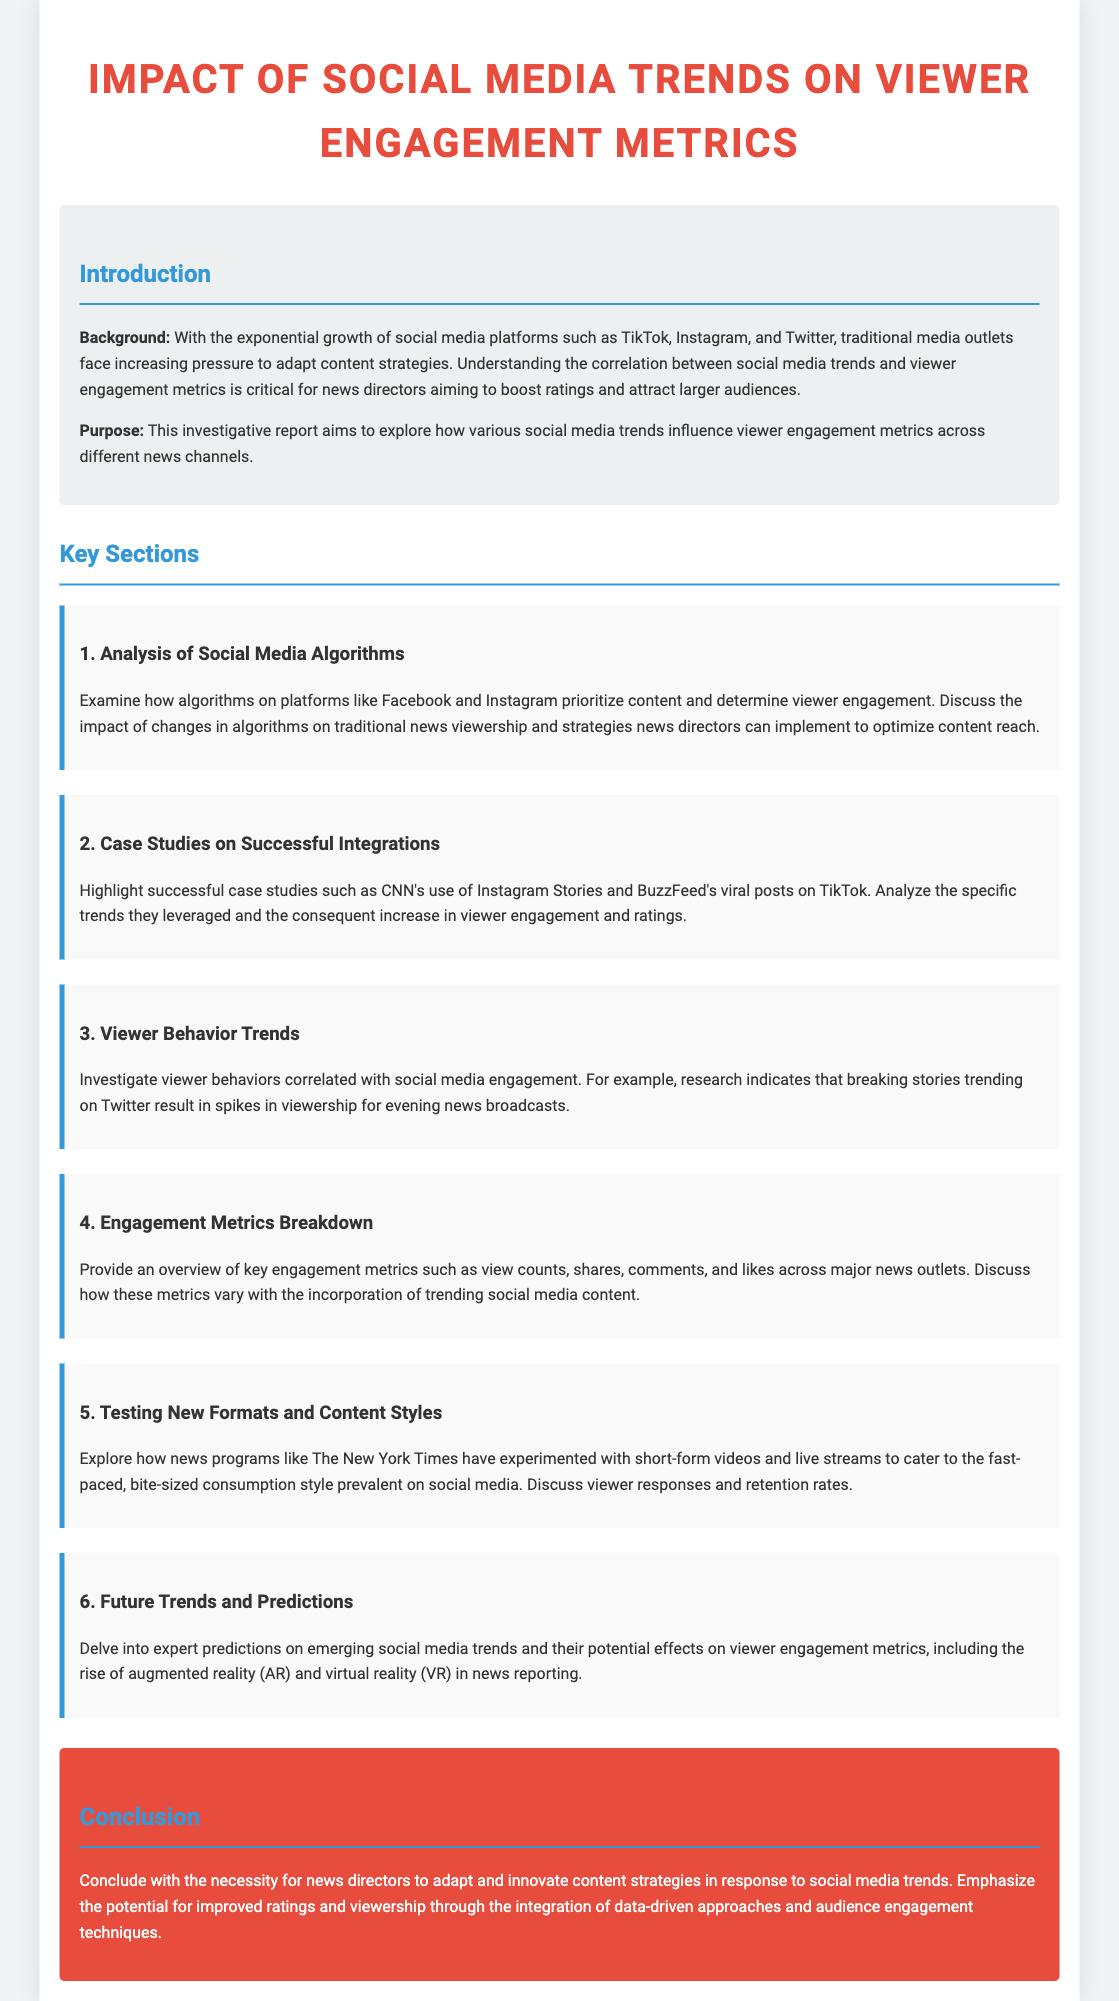What is the title of the report? The title of the report is prominently displayed as the main heading in the document.
Answer: Impact of Social Media Trends on Viewer Engagement Metrics What are the social media platforms mentioned? The social media platforms referenced in the introduction include TikTok, Instagram, and Twitter.
Answer: TikTok, Instagram, Twitter What is a key engagement metric discussed in the report? The document specifically mentions several key engagement metrics, one of which is indicated in the respective section.
Answer: View counts Which successful case study is highlighted? A successful case study mentioned in the document is CNN's use of a specific social media feature for viewer engagement.
Answer: Instagram Stories What is the purpose of the investigative report? The purpose of the report is clearly stated in the introduction section.
Answer: Explore how various social media trends influence viewer engagement metrics How many key sections are outlined in the document? The document lists a total number of sections dedicated to the analysis of the topic.
Answer: Six What format is mentioned as being tested by news programs? The report discusses the experimentation with a particular content format prevalent in social media consumption.
Answer: Short-form videos What future technology trend is predicted to impact engagement metrics? The document hints at a specific emerging technology that could influence viewer engagement metrics in the future.
Answer: Augmented reality (AR) and virtual reality (VR) 